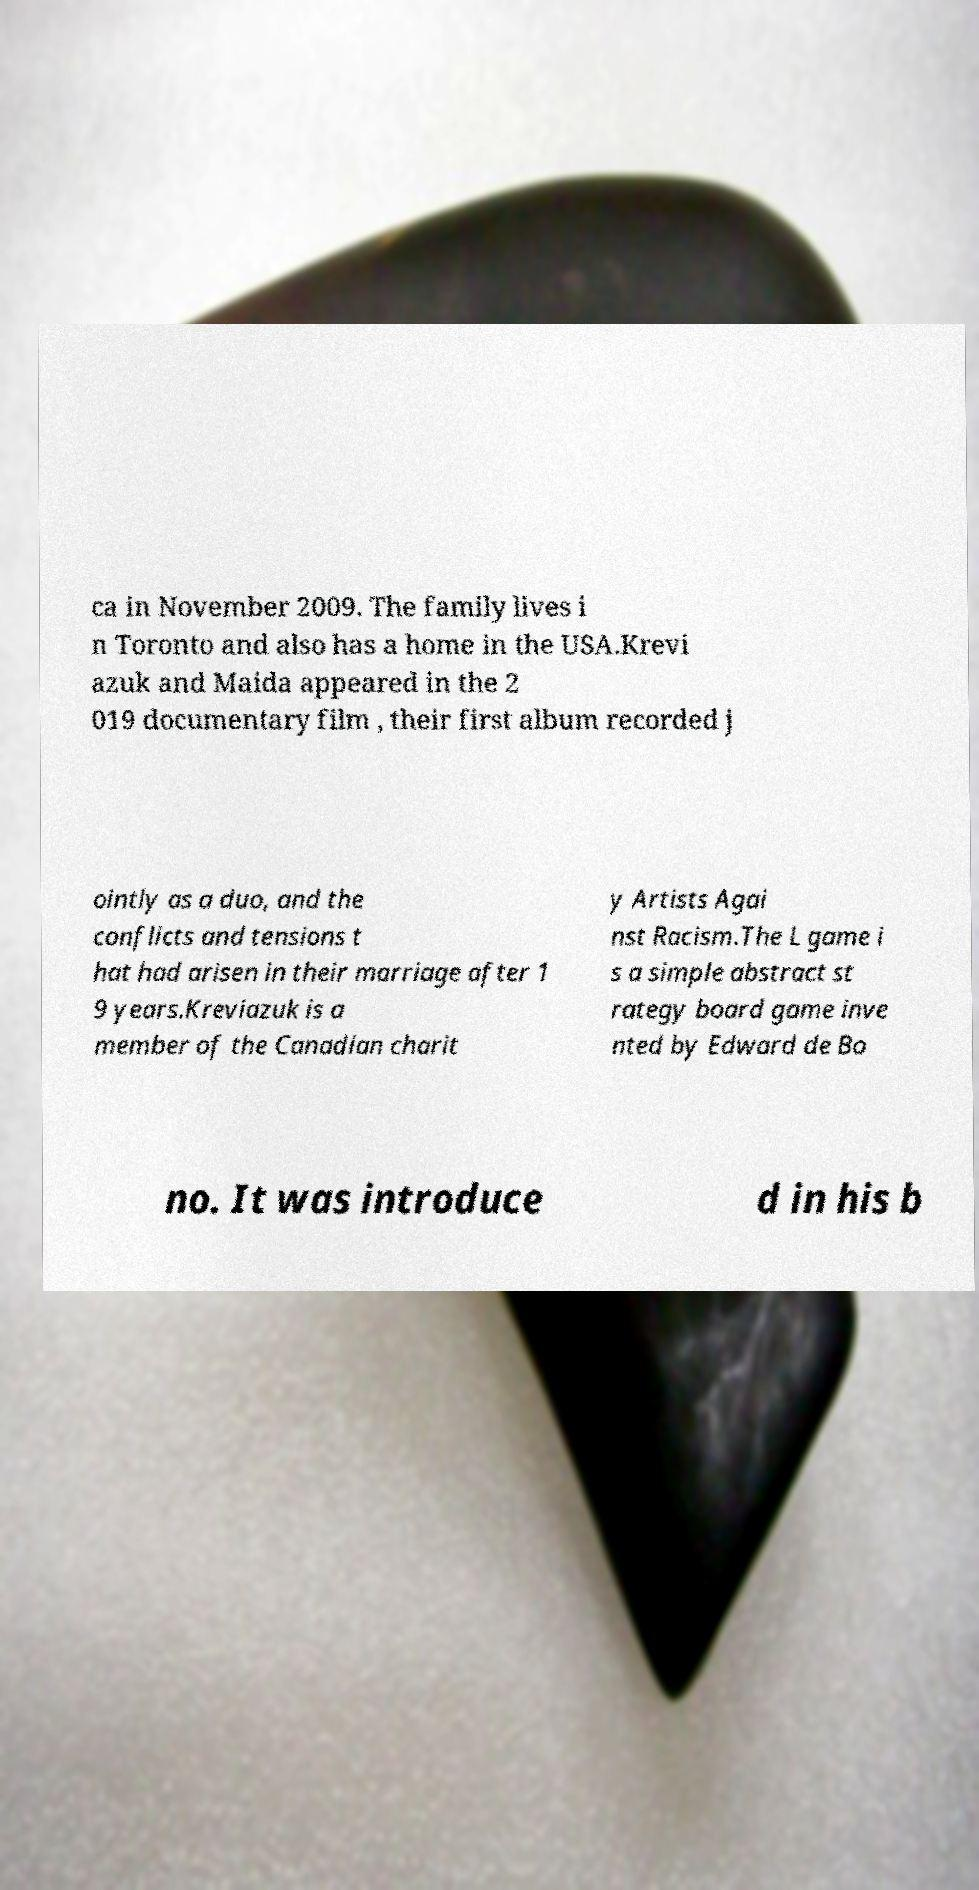Could you assist in decoding the text presented in this image and type it out clearly? ca in November 2009. The family lives i n Toronto and also has a home in the USA.Krevi azuk and Maida appeared in the 2 019 documentary film , their first album recorded j ointly as a duo, and the conflicts and tensions t hat had arisen in their marriage after 1 9 years.Kreviazuk is a member of the Canadian charit y Artists Agai nst Racism.The L game i s a simple abstract st rategy board game inve nted by Edward de Bo no. It was introduce d in his b 